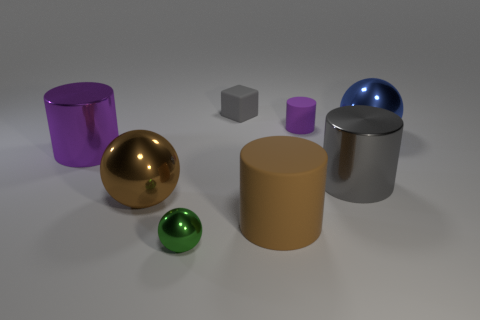Add 2 tiny green cylinders. How many objects exist? 10 Subtract all cubes. How many objects are left? 7 Add 8 purple matte things. How many purple matte things exist? 9 Subtract 1 gray cylinders. How many objects are left? 7 Subtract all large shiny things. Subtract all purple metallic spheres. How many objects are left? 4 Add 5 tiny green things. How many tiny green things are left? 6 